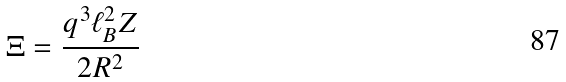<formula> <loc_0><loc_0><loc_500><loc_500>\Xi = \frac { q ^ { 3 } \ell _ { B } ^ { 2 } Z } { 2 R ^ { 2 } }</formula> 